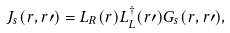Convert formula to latex. <formula><loc_0><loc_0><loc_500><loc_500>J _ { s } ( r , r \prime ) = L _ { R } ( r ) L _ { L } ^ { \dagger } ( r \prime ) G _ { s } ( r , r \prime ) ,</formula> 